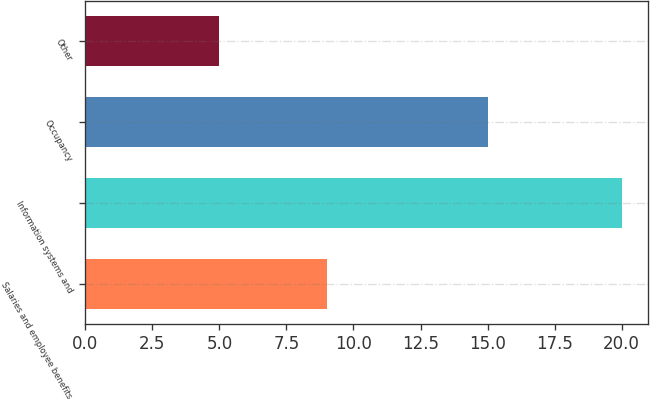<chart> <loc_0><loc_0><loc_500><loc_500><bar_chart><fcel>Salaries and employee benefits<fcel>Information systems and<fcel>Occupancy<fcel>Other<nl><fcel>9<fcel>20<fcel>15<fcel>5<nl></chart> 